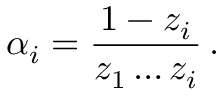Convert formula to latex. <formula><loc_0><loc_0><loc_500><loc_500>\alpha _ { i } = \frac { 1 - z _ { i } } { z _ { 1 } \dots z _ { i } } \, .</formula> 